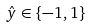Convert formula to latex. <formula><loc_0><loc_0><loc_500><loc_500>\hat { y } \in \{ - 1 , 1 \}</formula> 